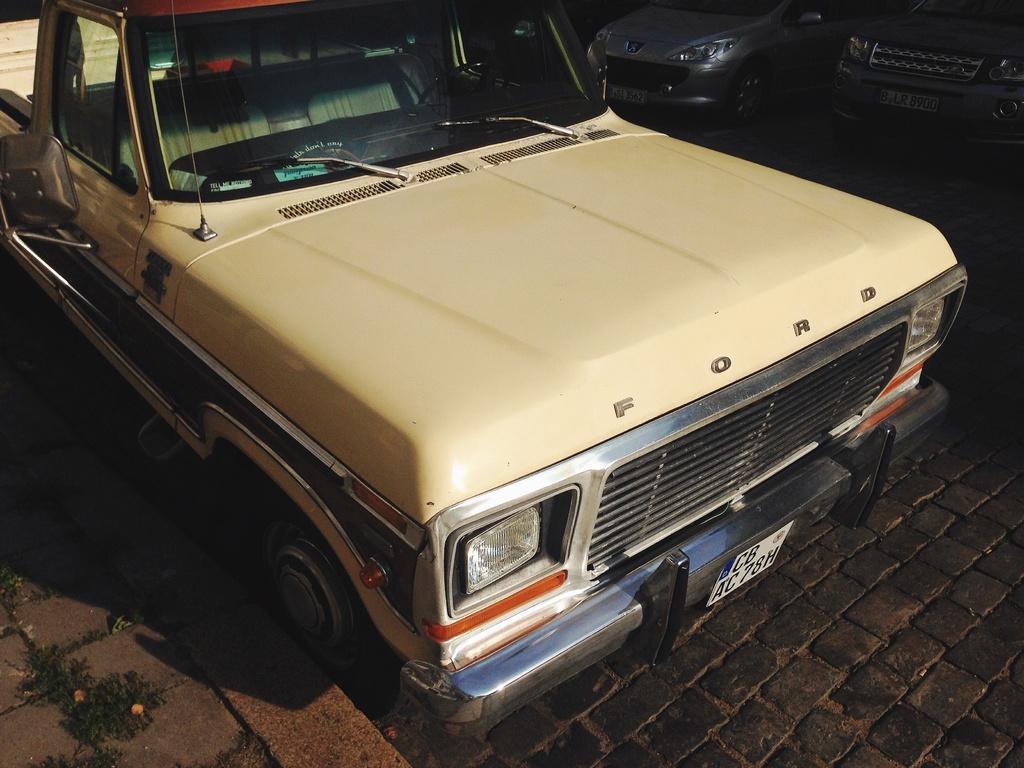In one or two sentences, can you explain what this image depicts? In this picture we can see car. On the top right corner we can see another two cars standing in the parking. 